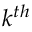<formula> <loc_0><loc_0><loc_500><loc_500>k ^ { t h }</formula> 